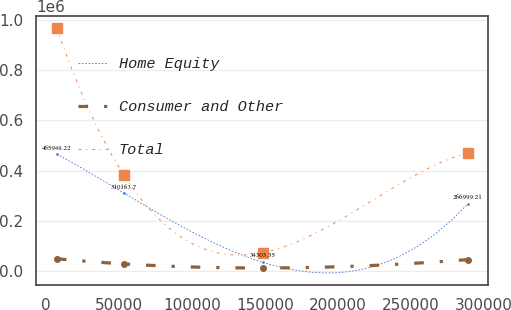Convert chart to OTSL. <chart><loc_0><loc_0><loc_500><loc_500><line_chart><ecel><fcel>Home Equity<fcel>Consumer and Other<fcel>Total<nl><fcel>7430.24<fcel>465948<fcel>48661.3<fcel>967175<nl><fcel>53550.8<fcel>310164<fcel>28089.7<fcel>381402<nl><fcel>148918<fcel>34303.3<fcel>11930.2<fcel>73271.1<nl><fcel>289126<fcel>266999<fcel>45270.6<fcel>470792<nl></chart> 